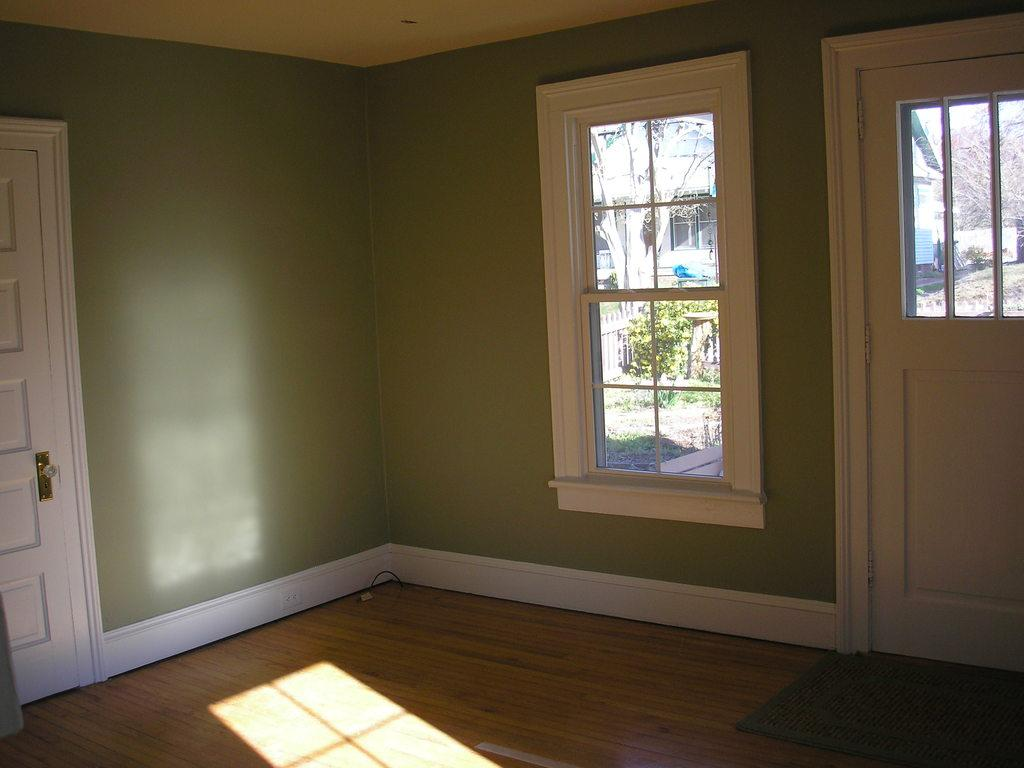Where was the image taken? The image was taken inside a room. What features can be seen in the room? There are windows and doors in the room. What can be seen through the windows? Trees are visible through the windows. What type of silk fabric is draped over the maid in the image? There is no maid or silk fabric present in the image. 